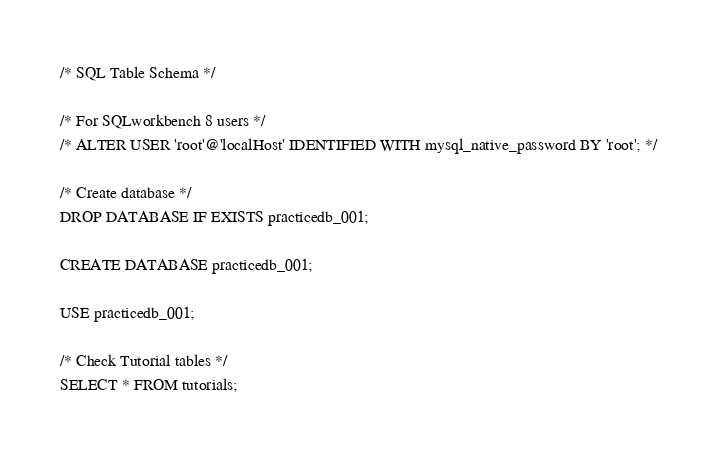Convert code to text. <code><loc_0><loc_0><loc_500><loc_500><_SQL_>/* SQL Table Schema */

/* For SQLworkbench 8 users */
/* ALTER USER 'root'@'localHost' IDENTIFIED WITH mysql_native_password BY 'root'; */

/* Create database */
DROP DATABASE IF EXISTS practicedb_001;

CREATE DATABASE practicedb_001;

USE practicedb_001;

/* Check Tutorial tables */
SELECT * FROM tutorials; </code> 